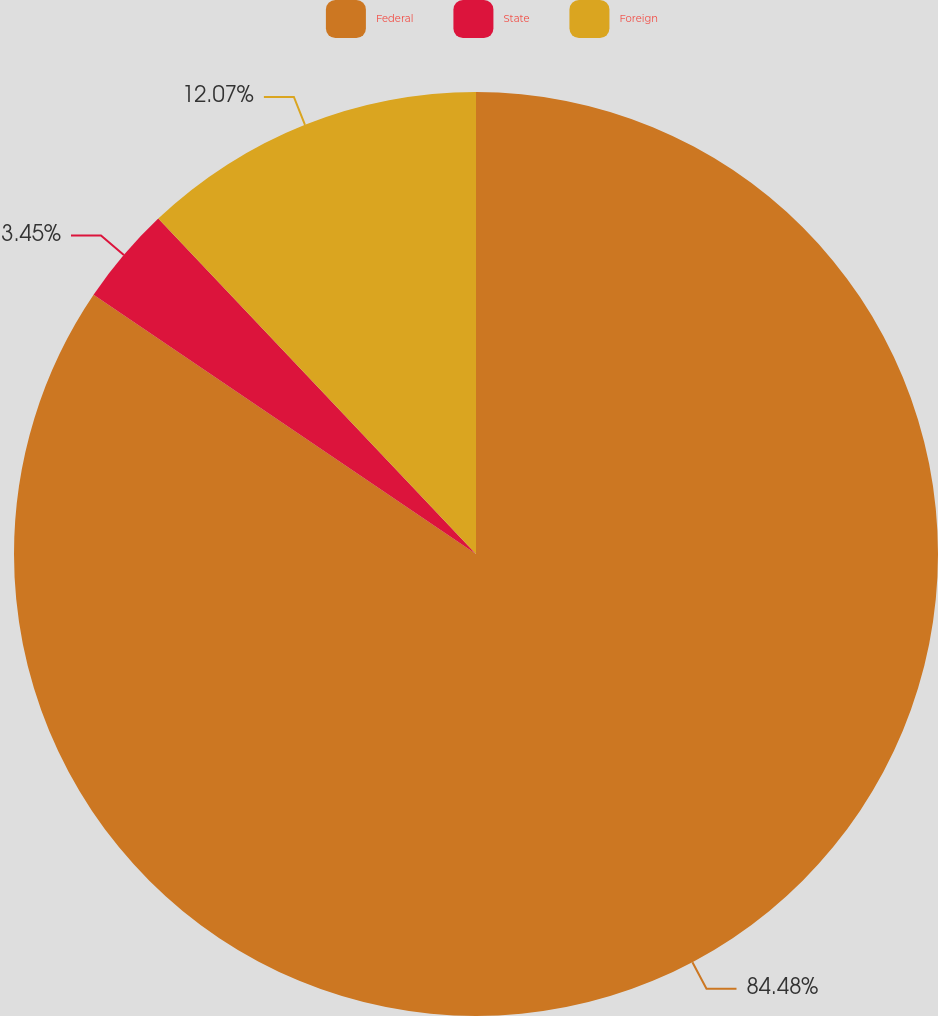<chart> <loc_0><loc_0><loc_500><loc_500><pie_chart><fcel>Federal<fcel>State<fcel>Foreign<nl><fcel>84.48%<fcel>3.45%<fcel>12.07%<nl></chart> 